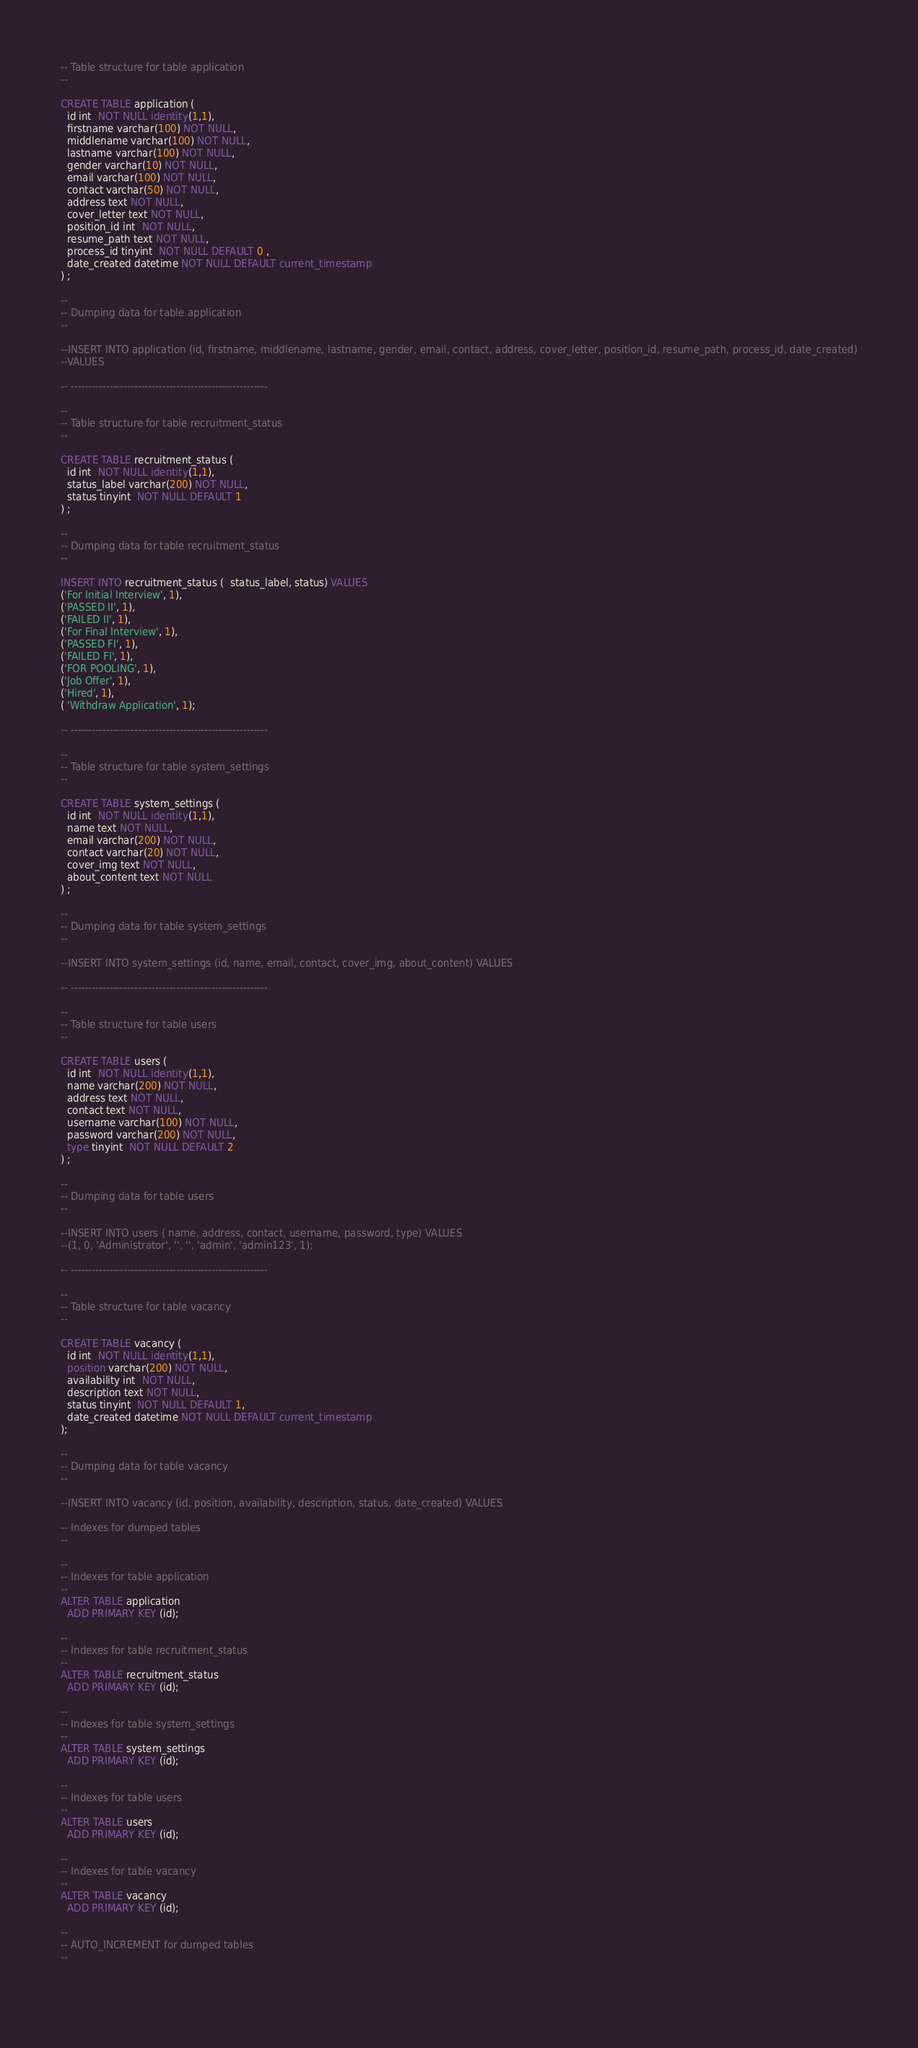Convert code to text. <code><loc_0><loc_0><loc_500><loc_500><_SQL_>






-- Table structure for table application
--

CREATE TABLE application (
  id int  NOT NULL identity(1,1),
  firstname varchar(100) NOT NULL,
  middlename varchar(100) NOT NULL,
  lastname varchar(100) NOT NULL,
  gender varchar(10) NOT NULL,
  email varchar(100) NOT NULL,
  contact varchar(50) NOT NULL,
  address text NOT NULL,
  cover_letter text NOT NULL,
  position_id int  NOT NULL,
  resume_path text NOT NULL,
  process_id tinyint  NOT NULL DEFAULT 0 ,
  date_created datetime NOT NULL DEFAULT current_timestamp
) ;

--
-- Dumping data for table application
--

--INSERT INTO application (id, firstname, middlename, lastname, gender, email, contact, address, cover_letter, position_id, resume_path, process_id, date_created)
--VALUES

-- --------------------------------------------------------

--
-- Table structure for table recruitment_status
--

CREATE TABLE recruitment_status (
  id int  NOT NULL identity(1,1),
  status_label varchar(200) NOT NULL,
  status tinyint  NOT NULL DEFAULT 1
) ;

--
-- Dumping data for table recruitment_status
--

INSERT INTO recruitment_status (  status_label, status) VALUES
('For Initial Interview', 1),
('PASSED II', 1),
('FAILED II', 1),
('For Final Interview', 1),
('PASSED FI', 1),
('FAILED FI', 1),
('FOR POOLING', 1),
('Job Offer', 1),
('Hired', 1),
( 'Withdraw Application', 1);

-- --------------------------------------------------------

--
-- Table structure for table system_settings
--

CREATE TABLE system_settings (
  id int  NOT NULL identity(1,1),
  name text NOT NULL,
  email varchar(200) NOT NULL,
  contact varchar(20) NOT NULL,
  cover_img text NOT NULL,
  about_content text NOT NULL
) ;

--
-- Dumping data for table system_settings
--

--INSERT INTO system_settings (id, name, email, contact, cover_img, about_content) VALUES

-- --------------------------------------------------------

--
-- Table structure for table users
--

CREATE TABLE users (
  id int  NOT NULL identity(1,1),
  name varchar(200) NOT NULL,
  address text NOT NULL,
  contact text NOT NULL,
  username varchar(100) NOT NULL,
  password varchar(200) NOT NULL,
  type tinyint  NOT NULL DEFAULT 2  
) ;

--
-- Dumping data for table users
--

--INSERT INTO users ( name, address, contact, username, password, type) VALUES
--(1, 0, 'Administrator', '', '', 'admin', 'admin123', 1);

-- --------------------------------------------------------

--
-- Table structure for table vacancy
--

CREATE TABLE vacancy (
  id int  NOT NULL identity(1,1),
  position varchar(200) NOT NULL,
  availability int  NOT NULL,
  description text NOT NULL,
  status tinyint  NOT NULL DEFAULT 1,
  date_created datetime NOT NULL DEFAULT current_timestamp
);

--
-- Dumping data for table vacancy
--

--INSERT INTO vacancy (id, position, availability, description, status, date_created) VALUES

-- Indexes for dumped tables
--

--
-- Indexes for table application
--
ALTER TABLE application
  ADD PRIMARY KEY (id);

--
-- Indexes for table recruitment_status
--
ALTER TABLE recruitment_status
  ADD PRIMARY KEY (id);

--
-- Indexes for table system_settings
--
ALTER TABLE system_settings
  ADD PRIMARY KEY (id);

--
-- Indexes for table users
--
ALTER TABLE users
  ADD PRIMARY KEY (id);

--
-- Indexes for table vacancy
--
ALTER TABLE vacancy
  ADD PRIMARY KEY (id);

--
-- AUTO_INCREMENT for dumped tables
--

 </code> 